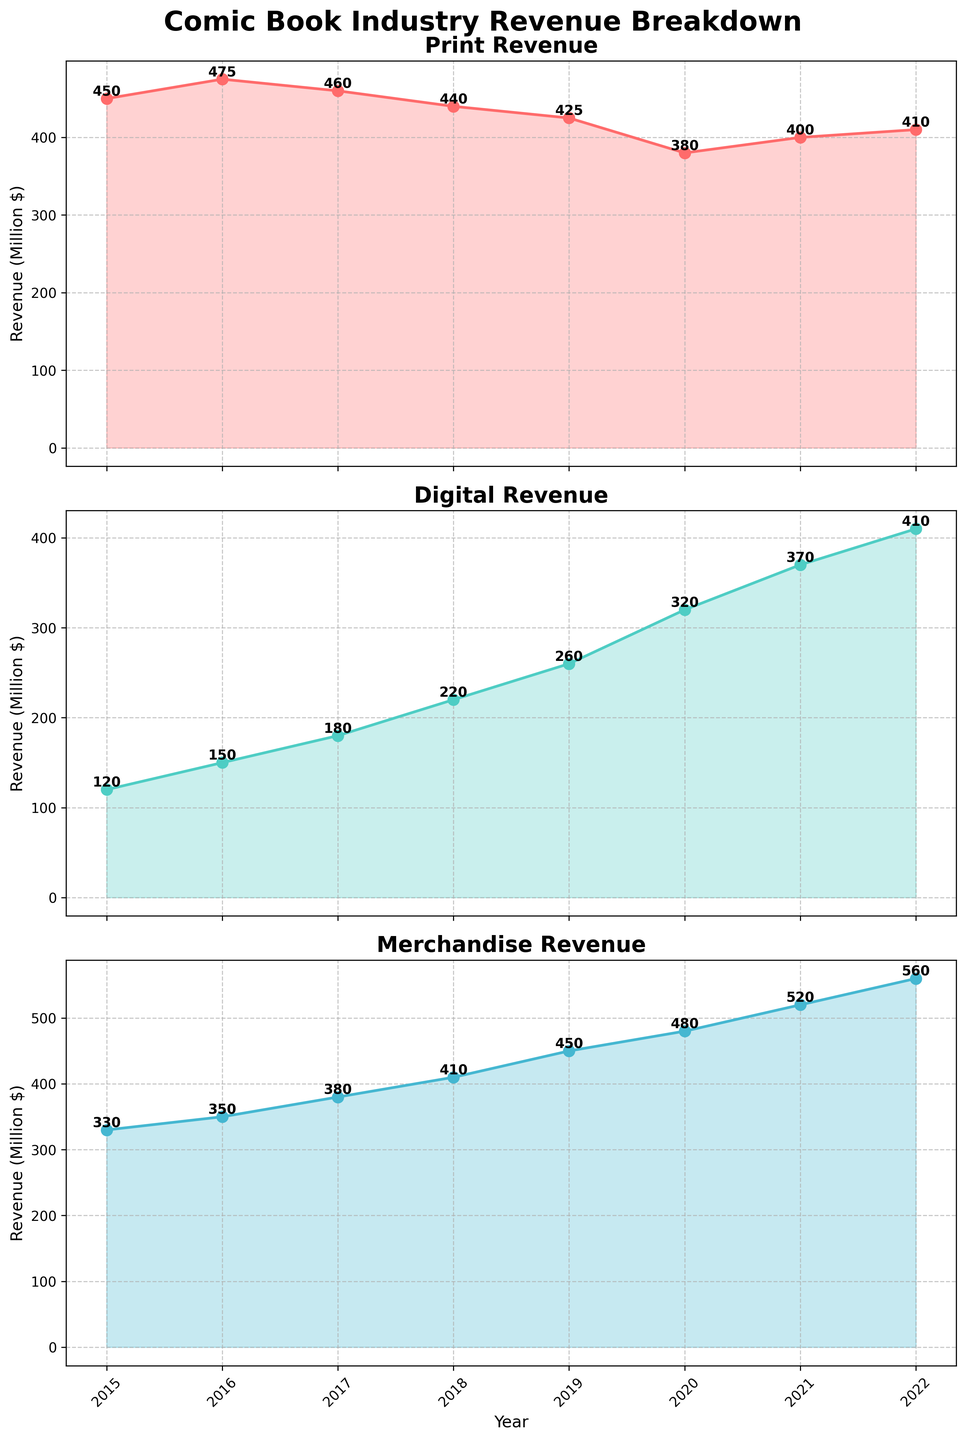What year did Digital revenue surpass 300 million dollars? Look at the Digital Revenue subplot and find the year where the line crosses the 300 million dollar mark. The line crosses above 300 in the year 2020.
Answer: 2020 Which category showed the highest revenue in 2022? Compare the final points of all subplots for the year 2022, looking for the highest value. Merchandise has the highest revenue at 560 million dollars.
Answer: Merchandise By how much did Print revenue decrease from 2015 to 2020? Subtract the Print revenue in 2020 (380 million) from the Print revenue in 2015 (450 million). The decrease is 450 - 380 = 70 million dollars.
Answer: 70 million dollars What was the combined revenue of all categories in 2018? Sum the revenues of Print (440 million), Digital (220 million), and Merchandise (410 million) for 2018. The combined revenue is 440 + 220 + 410 = 1070 million dollars.
Answer: 1070 million dollars What is the average annual growth rate of Digital revenue from 2015 to 2022? First, find the initial (120 million in 2015) and final (410 million in 2022) values. The growth rate is \( \left(\frac{410}{120}\right)^{\frac{1}{7}} - 1 = 0.190 \approx 19.0%\).
Answer: 19.0% Which category had the most consistent revenue pattern from 2015 to 2022? Observe the three subplots. The Merchandise revenue steadily increases each year, showing the least variance.
Answer: Merchandise In which year did Merchandise revenue first surpass 450 million dollars? Look at the Merchandise Revenue subplot and find the year where the line crosses above 450 million dollars. This occurs in 2019.
Answer: 2019 By how much did the combined revenue of all categories increase from 2015 to 2022? Calculate the total revenue for 2015 (450 + 120 + 330 = 900 million) and for 2022 (410 + 410 + 560 = 1380 million), then subtract the 2015 total from the 2022 total. The increase is 1380 - 900 = 480 million dollars.
Answer: 480 million dollars Which year saw the steepest increase in Digital revenue? Compare the year-to-year increments in the Digital Revenue subplot. The steepest increase is between 2019 and 2020, from 260 to 320 million dollars.
Answer: 2019 to 2020 